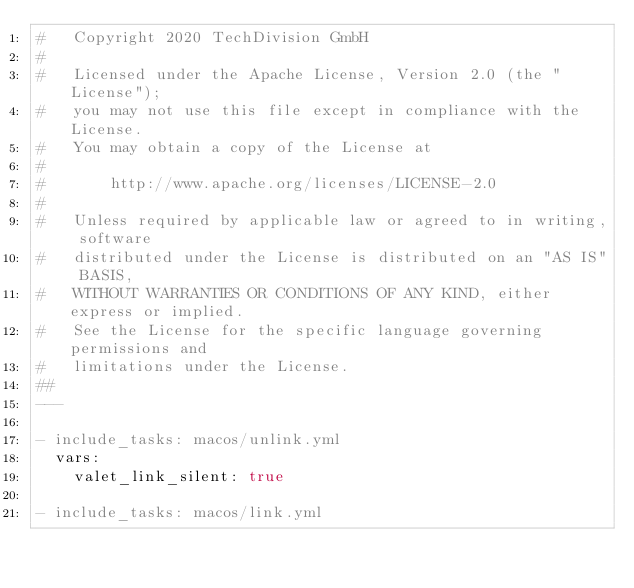Convert code to text. <code><loc_0><loc_0><loc_500><loc_500><_YAML_>#   Copyright 2020 TechDivision GmbH
#
#   Licensed under the Apache License, Version 2.0 (the "License");
#   you may not use this file except in compliance with the License.
#   You may obtain a copy of the License at
#
#       http://www.apache.org/licenses/LICENSE-2.0
#
#   Unless required by applicable law or agreed to in writing, software
#   distributed under the License is distributed on an "AS IS" BASIS,
#   WITHOUT WARRANTIES OR CONDITIONS OF ANY KIND, either express or implied.
#   See the License for the specific language governing permissions and
#   limitations under the License.
##
---

- include_tasks: macos/unlink.yml
  vars:
    valet_link_silent: true

- include_tasks: macos/link.yml</code> 